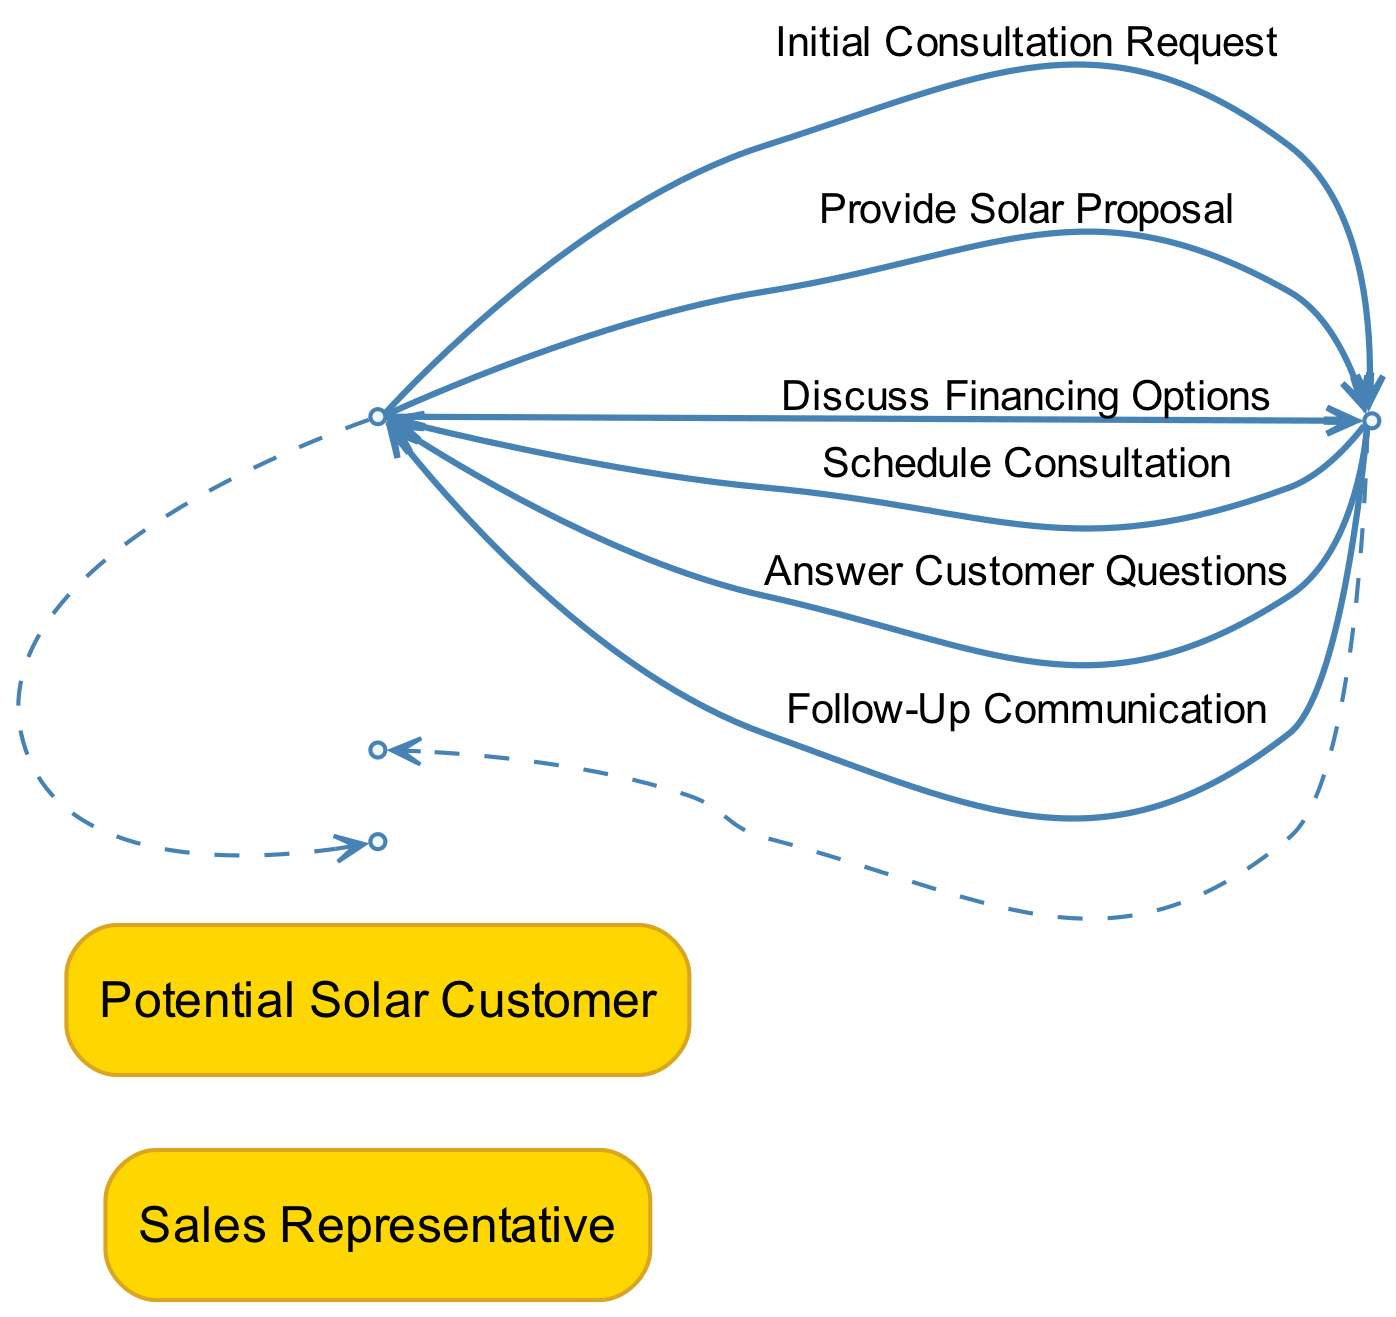What are the two actors in this diagram? The diagram features two actors: the Sales Representative and the Potential Solar Customer. These actors are explicitly labeled in the diagram, serving as the primary participants in the sequence of interactions.
Answer: Sales Representative, Potential Solar Customer How many messages are exchanged between the actors? The diagram depicts a total of six messages exchanged between the actors. Each message corresponds to an interaction that occurs during the consultation process, indicating the flow of communication.
Answer: Six What is the first message that is sent in the sequence? The first message in the sequence is the Initial Consultation Request, which the Potential Solar Customer sends to initiate the consultation process. This message is crucial as it starts the interaction.
Answer: Initial Consultation Request Which message follows the Provide Solar Proposal message? After the Provide Solar Proposal message, the next message in the sequence is Answer Customer Questions. This indicates a logical flow, where the sales representative addresses the customer's inquiries after presenting the proposal.
Answer: Answer Customer Questions What is the last message sent in the sequence? The last message in the sequence is the Follow-Up Communication. This message signifies the final step, where the sales representative reaches out to the potential customer after the consultation is complete.
Answer: Follow-Up Communication How does the sales representative address customer concerns? The sales representative addresses customer concerns through the message labeled Answer Customer Questions, demonstrating how they respond to inquiries and provide clarity during the consultation process.
Answer: Answer Customer Questions Which actor schedules the consultation? The Sales Representative is responsible for scheduling the consultation as indicated by the message Schedule Consultation. This highlights the proactive role of the sales rep in facilitating the appointment with the customer.
Answer: Sales Representative What message is sent immediately after the Schedule Consultation? The message sent immediately after the Schedule Consultation is Provide Solar Proposal. This illustrates the sequential flow of actions that follow the scheduling of a consultation, leading to the proposal presentation.
Answer: Provide Solar Proposal 